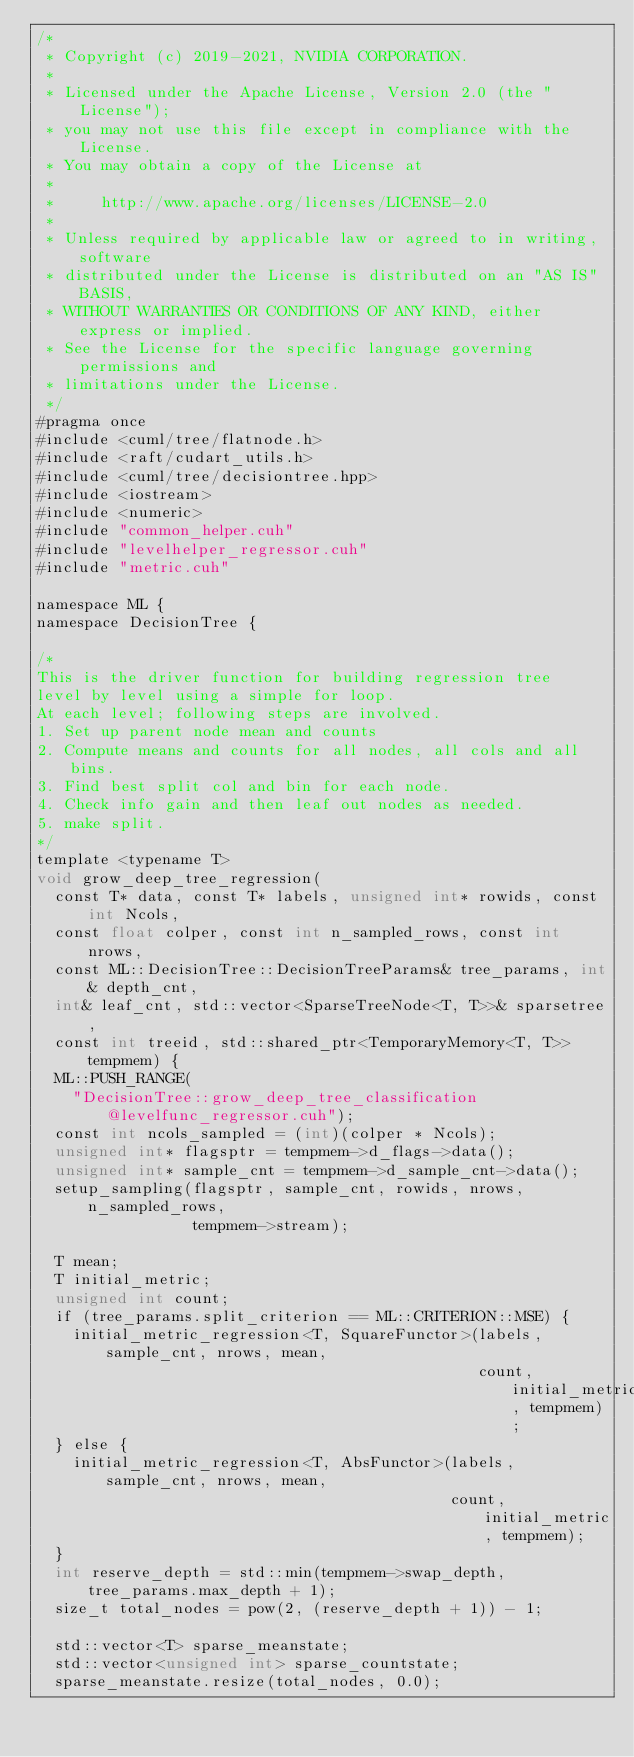Convert code to text. <code><loc_0><loc_0><loc_500><loc_500><_Cuda_>/*
 * Copyright (c) 2019-2021, NVIDIA CORPORATION.
 *
 * Licensed under the Apache License, Version 2.0 (the "License");
 * you may not use this file except in compliance with the License.
 * You may obtain a copy of the License at
 *
 *     http://www.apache.org/licenses/LICENSE-2.0
 *
 * Unless required by applicable law or agreed to in writing, software
 * distributed under the License is distributed on an "AS IS" BASIS,
 * WITHOUT WARRANTIES OR CONDITIONS OF ANY KIND, either express or implied.
 * See the License for the specific language governing permissions and
 * limitations under the License.
 */
#pragma once
#include <cuml/tree/flatnode.h>
#include <raft/cudart_utils.h>
#include <cuml/tree/decisiontree.hpp>
#include <iostream>
#include <numeric>
#include "common_helper.cuh"
#include "levelhelper_regressor.cuh"
#include "metric.cuh"

namespace ML {
namespace DecisionTree {

/*
This is the driver function for building regression tree
level by level using a simple for loop.
At each level; following steps are involved.
1. Set up parent node mean and counts
2. Compute means and counts for all nodes, all cols and all bins.
3. Find best split col and bin for each node.
4. Check info gain and then leaf out nodes as needed.
5. make split.
*/
template <typename T>
void grow_deep_tree_regression(
  const T* data, const T* labels, unsigned int* rowids, const int Ncols,
  const float colper, const int n_sampled_rows, const int nrows,
  const ML::DecisionTree::DecisionTreeParams& tree_params, int& depth_cnt,
  int& leaf_cnt, std::vector<SparseTreeNode<T, T>>& sparsetree,
  const int treeid, std::shared_ptr<TemporaryMemory<T, T>> tempmem) {
  ML::PUSH_RANGE(
    "DecisionTree::grow_deep_tree_classification @levelfunc_regressor.cuh");
  const int ncols_sampled = (int)(colper * Ncols);
  unsigned int* flagsptr = tempmem->d_flags->data();
  unsigned int* sample_cnt = tempmem->d_sample_cnt->data();
  setup_sampling(flagsptr, sample_cnt, rowids, nrows, n_sampled_rows,
                 tempmem->stream);

  T mean;
  T initial_metric;
  unsigned int count;
  if (tree_params.split_criterion == ML::CRITERION::MSE) {
    initial_metric_regression<T, SquareFunctor>(labels, sample_cnt, nrows, mean,
                                                count, initial_metric, tempmem);
  } else {
    initial_metric_regression<T, AbsFunctor>(labels, sample_cnt, nrows, mean,
                                             count, initial_metric, tempmem);
  }
  int reserve_depth = std::min(tempmem->swap_depth, tree_params.max_depth + 1);
  size_t total_nodes = pow(2, (reserve_depth + 1)) - 1;

  std::vector<T> sparse_meanstate;
  std::vector<unsigned int> sparse_countstate;
  sparse_meanstate.resize(total_nodes, 0.0);</code> 